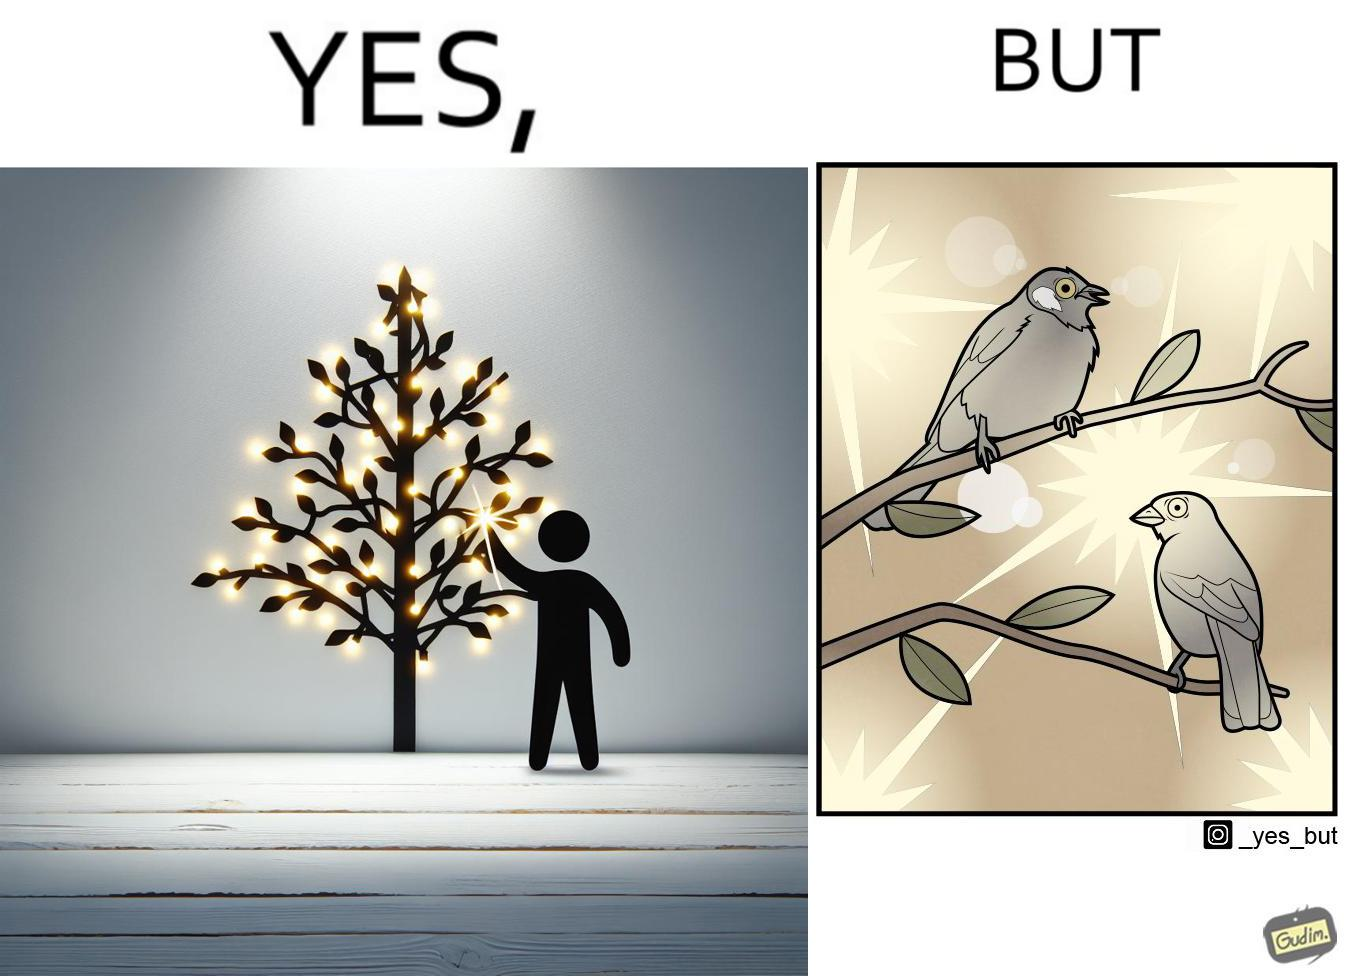Describe what you see in the left and right parts of this image. In the left part of the image: A tree decorated with lights all over it In the right part of the image: Birds dazzled by many lights 